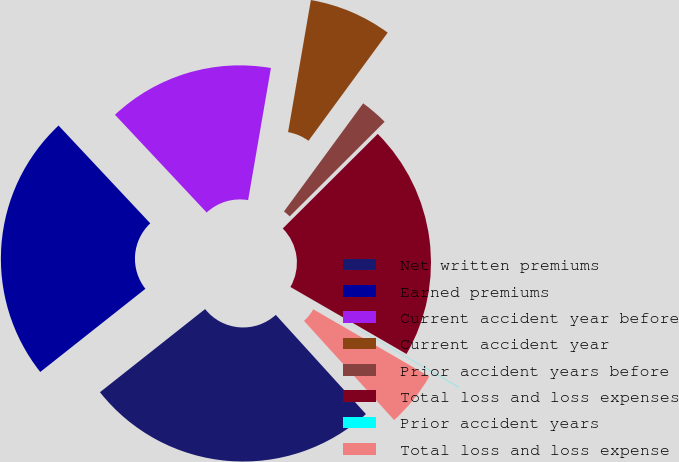<chart> <loc_0><loc_0><loc_500><loc_500><pie_chart><fcel>Net written premiums<fcel>Earned premiums<fcel>Current accident year before<fcel>Current accident year<fcel>Prior accident years before<fcel>Total loss and loss expenses<fcel>Prior accident years<fcel>Total loss and loss expense<nl><fcel>26.09%<fcel>23.66%<fcel>14.71%<fcel>7.34%<fcel>2.47%<fcel>20.8%<fcel>0.03%<fcel>4.9%<nl></chart> 